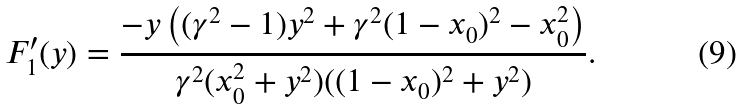<formula> <loc_0><loc_0><loc_500><loc_500>F _ { 1 } ^ { \prime } ( y ) = \frac { - y \left ( ( \gamma ^ { 2 } - 1 ) y ^ { 2 } + \gamma ^ { 2 } ( 1 - x _ { 0 } ) ^ { 2 } - x _ { 0 } ^ { 2 } \right ) } { \gamma ^ { 2 } ( x _ { 0 } ^ { 2 } + y ^ { 2 } ) ( ( 1 - x _ { 0 } ) ^ { 2 } + y ^ { 2 } ) } .</formula> 